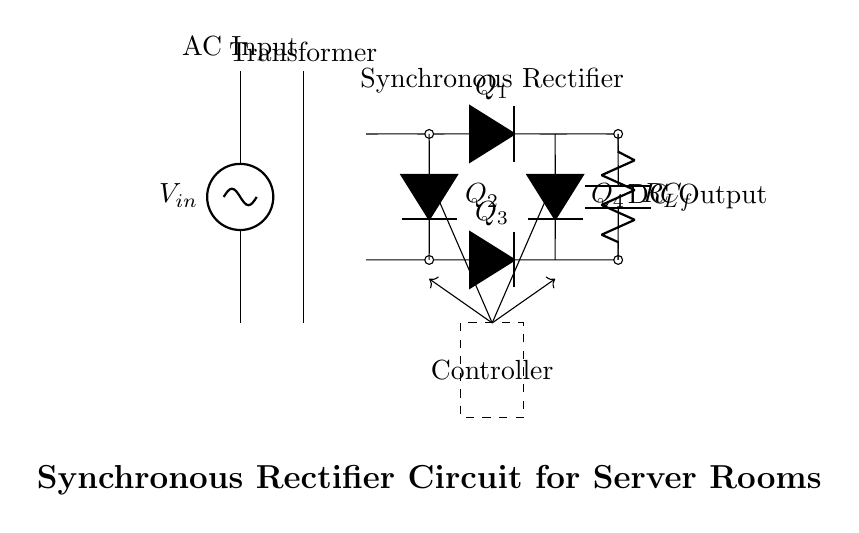What is the type of input for this circuit? The input is an AC voltage source, as indicated by the symbol labeled V_in at the top left corner.
Answer: AC Input How many diodes are present in the circuit? The circuit has four diodes, labeled Q1, Q2, Q3, and Q4, which are seen in the bridge rectifier configuration.
Answer: Four What is the role of the transformer in this circuit? The transformer is used to step up or step down the input AC voltage before rectification. It is located between the AC input and the rectifier diodes.
Answer: Voltage transformation Where is the output of the synchronous rectifier located? The DC output can be found on the right side of the circuit, connected to the capacitor labeled C_f and the load resistor labeled R_L.
Answer: DC Output What component manages the control signals in this circuit? The dashed rectangle labeled "Controller" manages the control signals that drive the diodes, making the operation of the synchronous rectifier more efficient.
Answer: Controller How does the synchronous rectifier improve energy efficiency? By using transistors instead of diodes, the synchronous rectifier minimizes conduction losses, allowing for higher efficiency in converting AC to DC, particularly important in server rooms.
Answer: Reduced conduction losses 